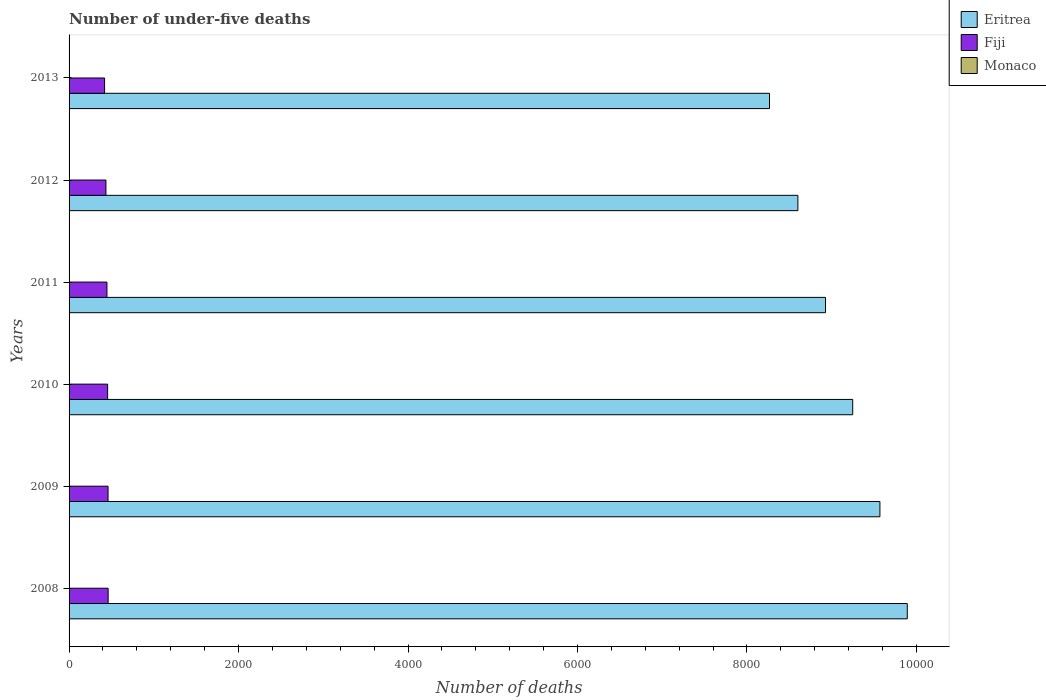How many different coloured bars are there?
Keep it short and to the point. 3. Are the number of bars on each tick of the Y-axis equal?
Your response must be concise. Yes. What is the number of under-five deaths in Monaco in 2008?
Ensure brevity in your answer.  1. Across all years, what is the maximum number of under-five deaths in Fiji?
Make the answer very short. 461. Across all years, what is the minimum number of under-five deaths in Fiji?
Your response must be concise. 419. In which year was the number of under-five deaths in Fiji maximum?
Your response must be concise. 2008. What is the difference between the number of under-five deaths in Fiji in 2012 and that in 2013?
Ensure brevity in your answer.  16. What is the difference between the number of under-five deaths in Monaco in 2010 and the number of under-five deaths in Eritrea in 2009?
Your answer should be very brief. -9568. What is the average number of under-five deaths in Fiji per year?
Give a very brief answer. 446.17. In the year 2010, what is the difference between the number of under-five deaths in Eritrea and number of under-five deaths in Monaco?
Your answer should be very brief. 9247. Is the number of under-five deaths in Eritrea in 2009 less than that in 2012?
Give a very brief answer. No. Is the difference between the number of under-five deaths in Eritrea in 2008 and 2009 greater than the difference between the number of under-five deaths in Monaco in 2008 and 2009?
Offer a very short reply. Yes. What is the difference between the highest and the second highest number of under-five deaths in Eritrea?
Your answer should be compact. 323. What is the difference between the highest and the lowest number of under-five deaths in Eritrea?
Provide a short and direct response. 1626. What does the 2nd bar from the top in 2008 represents?
Offer a terse response. Fiji. What does the 2nd bar from the bottom in 2010 represents?
Ensure brevity in your answer.  Fiji. How many bars are there?
Provide a short and direct response. 18. Are all the bars in the graph horizontal?
Provide a short and direct response. Yes. Are the values on the major ticks of X-axis written in scientific E-notation?
Provide a succinct answer. No. Does the graph contain grids?
Ensure brevity in your answer.  No. Where does the legend appear in the graph?
Keep it short and to the point. Top right. How many legend labels are there?
Make the answer very short. 3. What is the title of the graph?
Offer a terse response. Number of under-five deaths. Does "Timor-Leste" appear as one of the legend labels in the graph?
Provide a succinct answer. No. What is the label or title of the X-axis?
Keep it short and to the point. Number of deaths. What is the Number of deaths of Eritrea in 2008?
Give a very brief answer. 9892. What is the Number of deaths in Fiji in 2008?
Offer a terse response. 461. What is the Number of deaths in Eritrea in 2009?
Provide a short and direct response. 9569. What is the Number of deaths of Fiji in 2009?
Give a very brief answer. 460. What is the Number of deaths in Eritrea in 2010?
Provide a short and direct response. 9248. What is the Number of deaths in Fiji in 2010?
Provide a succinct answer. 455. What is the Number of deaths in Eritrea in 2011?
Your answer should be very brief. 8927. What is the Number of deaths in Fiji in 2011?
Provide a short and direct response. 447. What is the Number of deaths in Eritrea in 2012?
Your answer should be compact. 8601. What is the Number of deaths in Fiji in 2012?
Offer a terse response. 435. What is the Number of deaths of Monaco in 2012?
Provide a short and direct response. 1. What is the Number of deaths in Eritrea in 2013?
Offer a very short reply. 8266. What is the Number of deaths in Fiji in 2013?
Make the answer very short. 419. Across all years, what is the maximum Number of deaths in Eritrea?
Your response must be concise. 9892. Across all years, what is the maximum Number of deaths of Fiji?
Ensure brevity in your answer.  461. Across all years, what is the maximum Number of deaths of Monaco?
Your response must be concise. 1. Across all years, what is the minimum Number of deaths in Eritrea?
Give a very brief answer. 8266. Across all years, what is the minimum Number of deaths in Fiji?
Provide a succinct answer. 419. What is the total Number of deaths of Eritrea in the graph?
Provide a succinct answer. 5.45e+04. What is the total Number of deaths in Fiji in the graph?
Provide a short and direct response. 2677. What is the total Number of deaths in Monaco in the graph?
Give a very brief answer. 6. What is the difference between the Number of deaths in Eritrea in 2008 and that in 2009?
Ensure brevity in your answer.  323. What is the difference between the Number of deaths in Fiji in 2008 and that in 2009?
Offer a very short reply. 1. What is the difference between the Number of deaths of Monaco in 2008 and that in 2009?
Provide a short and direct response. 0. What is the difference between the Number of deaths of Eritrea in 2008 and that in 2010?
Provide a short and direct response. 644. What is the difference between the Number of deaths of Fiji in 2008 and that in 2010?
Your response must be concise. 6. What is the difference between the Number of deaths of Monaco in 2008 and that in 2010?
Keep it short and to the point. 0. What is the difference between the Number of deaths in Eritrea in 2008 and that in 2011?
Ensure brevity in your answer.  965. What is the difference between the Number of deaths in Monaco in 2008 and that in 2011?
Your response must be concise. 0. What is the difference between the Number of deaths in Eritrea in 2008 and that in 2012?
Offer a very short reply. 1291. What is the difference between the Number of deaths in Monaco in 2008 and that in 2012?
Make the answer very short. 0. What is the difference between the Number of deaths in Eritrea in 2008 and that in 2013?
Provide a succinct answer. 1626. What is the difference between the Number of deaths of Monaco in 2008 and that in 2013?
Give a very brief answer. 0. What is the difference between the Number of deaths of Eritrea in 2009 and that in 2010?
Ensure brevity in your answer.  321. What is the difference between the Number of deaths in Fiji in 2009 and that in 2010?
Provide a short and direct response. 5. What is the difference between the Number of deaths in Monaco in 2009 and that in 2010?
Your answer should be compact. 0. What is the difference between the Number of deaths of Eritrea in 2009 and that in 2011?
Provide a succinct answer. 642. What is the difference between the Number of deaths in Monaco in 2009 and that in 2011?
Your answer should be compact. 0. What is the difference between the Number of deaths of Eritrea in 2009 and that in 2012?
Offer a very short reply. 968. What is the difference between the Number of deaths of Eritrea in 2009 and that in 2013?
Your response must be concise. 1303. What is the difference between the Number of deaths in Fiji in 2009 and that in 2013?
Offer a very short reply. 41. What is the difference between the Number of deaths in Monaco in 2009 and that in 2013?
Offer a very short reply. 0. What is the difference between the Number of deaths of Eritrea in 2010 and that in 2011?
Ensure brevity in your answer.  321. What is the difference between the Number of deaths of Fiji in 2010 and that in 2011?
Ensure brevity in your answer.  8. What is the difference between the Number of deaths in Monaco in 2010 and that in 2011?
Make the answer very short. 0. What is the difference between the Number of deaths in Eritrea in 2010 and that in 2012?
Give a very brief answer. 647. What is the difference between the Number of deaths in Fiji in 2010 and that in 2012?
Provide a short and direct response. 20. What is the difference between the Number of deaths of Monaco in 2010 and that in 2012?
Keep it short and to the point. 0. What is the difference between the Number of deaths of Eritrea in 2010 and that in 2013?
Provide a short and direct response. 982. What is the difference between the Number of deaths of Monaco in 2010 and that in 2013?
Ensure brevity in your answer.  0. What is the difference between the Number of deaths of Eritrea in 2011 and that in 2012?
Your answer should be very brief. 326. What is the difference between the Number of deaths of Monaco in 2011 and that in 2012?
Your answer should be very brief. 0. What is the difference between the Number of deaths in Eritrea in 2011 and that in 2013?
Offer a very short reply. 661. What is the difference between the Number of deaths in Eritrea in 2012 and that in 2013?
Your answer should be compact. 335. What is the difference between the Number of deaths of Eritrea in 2008 and the Number of deaths of Fiji in 2009?
Your answer should be very brief. 9432. What is the difference between the Number of deaths in Eritrea in 2008 and the Number of deaths in Monaco in 2009?
Give a very brief answer. 9891. What is the difference between the Number of deaths of Fiji in 2008 and the Number of deaths of Monaco in 2009?
Offer a very short reply. 460. What is the difference between the Number of deaths of Eritrea in 2008 and the Number of deaths of Fiji in 2010?
Provide a succinct answer. 9437. What is the difference between the Number of deaths in Eritrea in 2008 and the Number of deaths in Monaco in 2010?
Keep it short and to the point. 9891. What is the difference between the Number of deaths in Fiji in 2008 and the Number of deaths in Monaco in 2010?
Your response must be concise. 460. What is the difference between the Number of deaths of Eritrea in 2008 and the Number of deaths of Fiji in 2011?
Your answer should be very brief. 9445. What is the difference between the Number of deaths of Eritrea in 2008 and the Number of deaths of Monaco in 2011?
Provide a succinct answer. 9891. What is the difference between the Number of deaths in Fiji in 2008 and the Number of deaths in Monaco in 2011?
Provide a short and direct response. 460. What is the difference between the Number of deaths of Eritrea in 2008 and the Number of deaths of Fiji in 2012?
Your response must be concise. 9457. What is the difference between the Number of deaths in Eritrea in 2008 and the Number of deaths in Monaco in 2012?
Your response must be concise. 9891. What is the difference between the Number of deaths in Fiji in 2008 and the Number of deaths in Monaco in 2012?
Give a very brief answer. 460. What is the difference between the Number of deaths in Eritrea in 2008 and the Number of deaths in Fiji in 2013?
Your response must be concise. 9473. What is the difference between the Number of deaths of Eritrea in 2008 and the Number of deaths of Monaco in 2013?
Ensure brevity in your answer.  9891. What is the difference between the Number of deaths in Fiji in 2008 and the Number of deaths in Monaco in 2013?
Give a very brief answer. 460. What is the difference between the Number of deaths of Eritrea in 2009 and the Number of deaths of Fiji in 2010?
Keep it short and to the point. 9114. What is the difference between the Number of deaths in Eritrea in 2009 and the Number of deaths in Monaco in 2010?
Offer a very short reply. 9568. What is the difference between the Number of deaths of Fiji in 2009 and the Number of deaths of Monaco in 2010?
Ensure brevity in your answer.  459. What is the difference between the Number of deaths of Eritrea in 2009 and the Number of deaths of Fiji in 2011?
Provide a short and direct response. 9122. What is the difference between the Number of deaths in Eritrea in 2009 and the Number of deaths in Monaco in 2011?
Ensure brevity in your answer.  9568. What is the difference between the Number of deaths in Fiji in 2009 and the Number of deaths in Monaco in 2011?
Offer a terse response. 459. What is the difference between the Number of deaths in Eritrea in 2009 and the Number of deaths in Fiji in 2012?
Provide a succinct answer. 9134. What is the difference between the Number of deaths of Eritrea in 2009 and the Number of deaths of Monaco in 2012?
Offer a very short reply. 9568. What is the difference between the Number of deaths in Fiji in 2009 and the Number of deaths in Monaco in 2012?
Provide a succinct answer. 459. What is the difference between the Number of deaths in Eritrea in 2009 and the Number of deaths in Fiji in 2013?
Provide a succinct answer. 9150. What is the difference between the Number of deaths of Eritrea in 2009 and the Number of deaths of Monaco in 2013?
Give a very brief answer. 9568. What is the difference between the Number of deaths in Fiji in 2009 and the Number of deaths in Monaco in 2013?
Keep it short and to the point. 459. What is the difference between the Number of deaths of Eritrea in 2010 and the Number of deaths of Fiji in 2011?
Provide a short and direct response. 8801. What is the difference between the Number of deaths of Eritrea in 2010 and the Number of deaths of Monaco in 2011?
Provide a succinct answer. 9247. What is the difference between the Number of deaths in Fiji in 2010 and the Number of deaths in Monaco in 2011?
Give a very brief answer. 454. What is the difference between the Number of deaths in Eritrea in 2010 and the Number of deaths in Fiji in 2012?
Make the answer very short. 8813. What is the difference between the Number of deaths of Eritrea in 2010 and the Number of deaths of Monaco in 2012?
Provide a succinct answer. 9247. What is the difference between the Number of deaths of Fiji in 2010 and the Number of deaths of Monaco in 2012?
Keep it short and to the point. 454. What is the difference between the Number of deaths in Eritrea in 2010 and the Number of deaths in Fiji in 2013?
Ensure brevity in your answer.  8829. What is the difference between the Number of deaths in Eritrea in 2010 and the Number of deaths in Monaco in 2013?
Keep it short and to the point. 9247. What is the difference between the Number of deaths in Fiji in 2010 and the Number of deaths in Monaco in 2013?
Your answer should be compact. 454. What is the difference between the Number of deaths of Eritrea in 2011 and the Number of deaths of Fiji in 2012?
Keep it short and to the point. 8492. What is the difference between the Number of deaths of Eritrea in 2011 and the Number of deaths of Monaco in 2012?
Provide a succinct answer. 8926. What is the difference between the Number of deaths in Fiji in 2011 and the Number of deaths in Monaco in 2012?
Your answer should be very brief. 446. What is the difference between the Number of deaths of Eritrea in 2011 and the Number of deaths of Fiji in 2013?
Your answer should be compact. 8508. What is the difference between the Number of deaths in Eritrea in 2011 and the Number of deaths in Monaco in 2013?
Your answer should be very brief. 8926. What is the difference between the Number of deaths of Fiji in 2011 and the Number of deaths of Monaco in 2013?
Your response must be concise. 446. What is the difference between the Number of deaths of Eritrea in 2012 and the Number of deaths of Fiji in 2013?
Ensure brevity in your answer.  8182. What is the difference between the Number of deaths of Eritrea in 2012 and the Number of deaths of Monaco in 2013?
Make the answer very short. 8600. What is the difference between the Number of deaths of Fiji in 2012 and the Number of deaths of Monaco in 2013?
Offer a terse response. 434. What is the average Number of deaths of Eritrea per year?
Your answer should be very brief. 9083.83. What is the average Number of deaths in Fiji per year?
Offer a very short reply. 446.17. In the year 2008, what is the difference between the Number of deaths in Eritrea and Number of deaths in Fiji?
Ensure brevity in your answer.  9431. In the year 2008, what is the difference between the Number of deaths in Eritrea and Number of deaths in Monaco?
Your response must be concise. 9891. In the year 2008, what is the difference between the Number of deaths of Fiji and Number of deaths of Monaco?
Your answer should be compact. 460. In the year 2009, what is the difference between the Number of deaths in Eritrea and Number of deaths in Fiji?
Ensure brevity in your answer.  9109. In the year 2009, what is the difference between the Number of deaths of Eritrea and Number of deaths of Monaco?
Offer a terse response. 9568. In the year 2009, what is the difference between the Number of deaths of Fiji and Number of deaths of Monaco?
Provide a short and direct response. 459. In the year 2010, what is the difference between the Number of deaths in Eritrea and Number of deaths in Fiji?
Keep it short and to the point. 8793. In the year 2010, what is the difference between the Number of deaths of Eritrea and Number of deaths of Monaco?
Offer a very short reply. 9247. In the year 2010, what is the difference between the Number of deaths of Fiji and Number of deaths of Monaco?
Keep it short and to the point. 454. In the year 2011, what is the difference between the Number of deaths of Eritrea and Number of deaths of Fiji?
Provide a short and direct response. 8480. In the year 2011, what is the difference between the Number of deaths in Eritrea and Number of deaths in Monaco?
Your response must be concise. 8926. In the year 2011, what is the difference between the Number of deaths of Fiji and Number of deaths of Monaco?
Give a very brief answer. 446. In the year 2012, what is the difference between the Number of deaths of Eritrea and Number of deaths of Fiji?
Provide a short and direct response. 8166. In the year 2012, what is the difference between the Number of deaths in Eritrea and Number of deaths in Monaco?
Give a very brief answer. 8600. In the year 2012, what is the difference between the Number of deaths in Fiji and Number of deaths in Monaco?
Give a very brief answer. 434. In the year 2013, what is the difference between the Number of deaths in Eritrea and Number of deaths in Fiji?
Offer a terse response. 7847. In the year 2013, what is the difference between the Number of deaths in Eritrea and Number of deaths in Monaco?
Your answer should be compact. 8265. In the year 2013, what is the difference between the Number of deaths of Fiji and Number of deaths of Monaco?
Make the answer very short. 418. What is the ratio of the Number of deaths of Eritrea in 2008 to that in 2009?
Your answer should be compact. 1.03. What is the ratio of the Number of deaths in Fiji in 2008 to that in 2009?
Make the answer very short. 1. What is the ratio of the Number of deaths of Monaco in 2008 to that in 2009?
Offer a terse response. 1. What is the ratio of the Number of deaths in Eritrea in 2008 to that in 2010?
Your response must be concise. 1.07. What is the ratio of the Number of deaths of Fiji in 2008 to that in 2010?
Provide a short and direct response. 1.01. What is the ratio of the Number of deaths of Monaco in 2008 to that in 2010?
Provide a succinct answer. 1. What is the ratio of the Number of deaths in Eritrea in 2008 to that in 2011?
Offer a terse response. 1.11. What is the ratio of the Number of deaths in Fiji in 2008 to that in 2011?
Keep it short and to the point. 1.03. What is the ratio of the Number of deaths in Eritrea in 2008 to that in 2012?
Your answer should be compact. 1.15. What is the ratio of the Number of deaths of Fiji in 2008 to that in 2012?
Give a very brief answer. 1.06. What is the ratio of the Number of deaths of Eritrea in 2008 to that in 2013?
Provide a succinct answer. 1.2. What is the ratio of the Number of deaths in Fiji in 2008 to that in 2013?
Provide a succinct answer. 1.1. What is the ratio of the Number of deaths in Eritrea in 2009 to that in 2010?
Keep it short and to the point. 1.03. What is the ratio of the Number of deaths in Monaco in 2009 to that in 2010?
Provide a succinct answer. 1. What is the ratio of the Number of deaths of Eritrea in 2009 to that in 2011?
Keep it short and to the point. 1.07. What is the ratio of the Number of deaths of Fiji in 2009 to that in 2011?
Provide a succinct answer. 1.03. What is the ratio of the Number of deaths of Monaco in 2009 to that in 2011?
Keep it short and to the point. 1. What is the ratio of the Number of deaths of Eritrea in 2009 to that in 2012?
Give a very brief answer. 1.11. What is the ratio of the Number of deaths of Fiji in 2009 to that in 2012?
Make the answer very short. 1.06. What is the ratio of the Number of deaths of Monaco in 2009 to that in 2012?
Ensure brevity in your answer.  1. What is the ratio of the Number of deaths in Eritrea in 2009 to that in 2013?
Your response must be concise. 1.16. What is the ratio of the Number of deaths of Fiji in 2009 to that in 2013?
Offer a terse response. 1.1. What is the ratio of the Number of deaths in Monaco in 2009 to that in 2013?
Keep it short and to the point. 1. What is the ratio of the Number of deaths in Eritrea in 2010 to that in 2011?
Provide a short and direct response. 1.04. What is the ratio of the Number of deaths of Fiji in 2010 to that in 2011?
Your answer should be compact. 1.02. What is the ratio of the Number of deaths of Eritrea in 2010 to that in 2012?
Keep it short and to the point. 1.08. What is the ratio of the Number of deaths of Fiji in 2010 to that in 2012?
Provide a succinct answer. 1.05. What is the ratio of the Number of deaths of Eritrea in 2010 to that in 2013?
Give a very brief answer. 1.12. What is the ratio of the Number of deaths of Fiji in 2010 to that in 2013?
Give a very brief answer. 1.09. What is the ratio of the Number of deaths in Eritrea in 2011 to that in 2012?
Ensure brevity in your answer.  1.04. What is the ratio of the Number of deaths of Fiji in 2011 to that in 2012?
Offer a very short reply. 1.03. What is the ratio of the Number of deaths of Eritrea in 2011 to that in 2013?
Make the answer very short. 1.08. What is the ratio of the Number of deaths of Fiji in 2011 to that in 2013?
Provide a short and direct response. 1.07. What is the ratio of the Number of deaths of Monaco in 2011 to that in 2013?
Make the answer very short. 1. What is the ratio of the Number of deaths of Eritrea in 2012 to that in 2013?
Your answer should be compact. 1.04. What is the ratio of the Number of deaths in Fiji in 2012 to that in 2013?
Your answer should be very brief. 1.04. What is the difference between the highest and the second highest Number of deaths in Eritrea?
Give a very brief answer. 323. What is the difference between the highest and the lowest Number of deaths of Eritrea?
Your answer should be very brief. 1626. What is the difference between the highest and the lowest Number of deaths in Fiji?
Provide a succinct answer. 42. What is the difference between the highest and the lowest Number of deaths in Monaco?
Your answer should be compact. 0. 